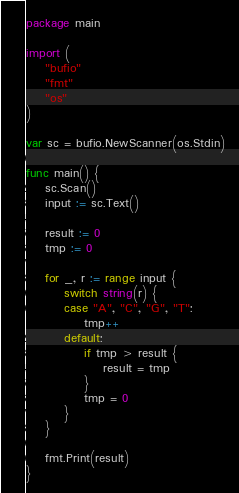Convert code to text. <code><loc_0><loc_0><loc_500><loc_500><_Go_>package main

import (
	"bufio"
	"fmt"
	"os"
)

var sc = bufio.NewScanner(os.Stdin)

func main() {
	sc.Scan()
	input := sc.Text()

	result := 0
	tmp := 0

	for _, r := range input {
		switch string(r) {
		case "A", "C", "G", "T":
			tmp++
		default:
			if tmp > result {
				result = tmp
			}
			tmp = 0
		}
	}

	fmt.Print(result)
}</code> 